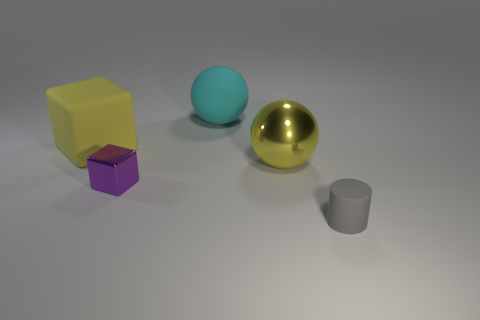Add 1 red cylinders. How many objects exist? 6 Subtract all balls. How many objects are left? 3 Add 2 large shiny objects. How many large shiny objects are left? 3 Add 2 tiny purple things. How many tiny purple things exist? 3 Subtract 0 red spheres. How many objects are left? 5 Subtract all big green shiny spheres. Subtract all gray matte objects. How many objects are left? 4 